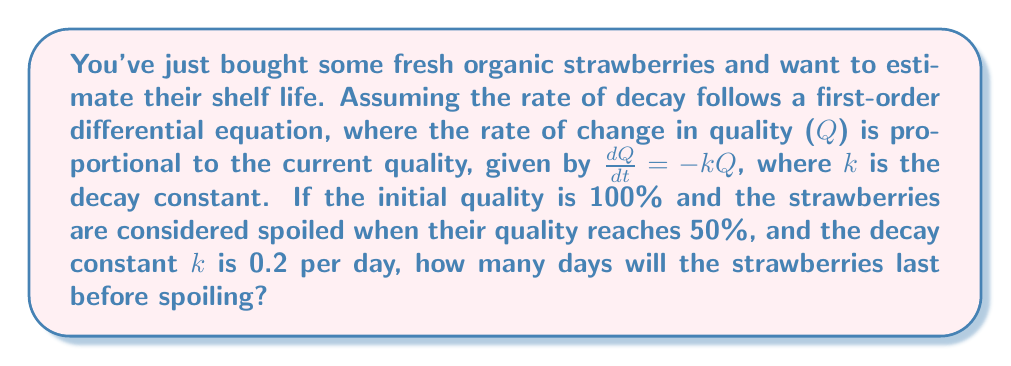Provide a solution to this math problem. To solve this problem, we'll use the first-order differential equation for decay:

1) The general solution to $\frac{dQ}{dt} = -kQ$ is:
   $Q(t) = Q_0e^{-kt}$

   Where $Q_0$ is the initial quality and t is time in days.

2) We're given:
   $Q_0 = 100\%$ (initial quality)
   $k = 0.2$ per day (decay constant)
   $Q(t) = 50\%$ (quality at spoilage)

3) Substituting these values into the general solution:
   $50 = 100e^{-0.2t}$

4) Dividing both sides by 100:
   $0.5 = e^{-0.2t}$

5) Taking the natural logarithm of both sides:
   $\ln(0.5) = -0.2t$

6) Solving for t:
   $t = \frac{\ln(0.5)}{-0.2} = \frac{-0.693}{-0.2} \approx 3.47$ days

Therefore, the strawberries will last approximately 3.47 days before spoiling.
Answer: 3.47 days 